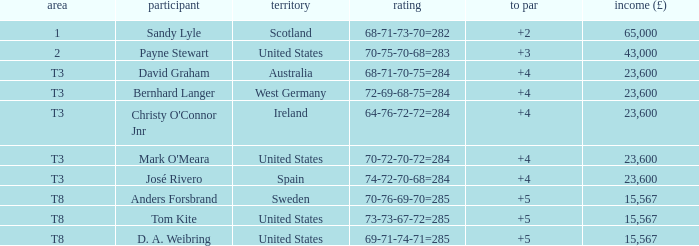What place is David Graham in? T3. 